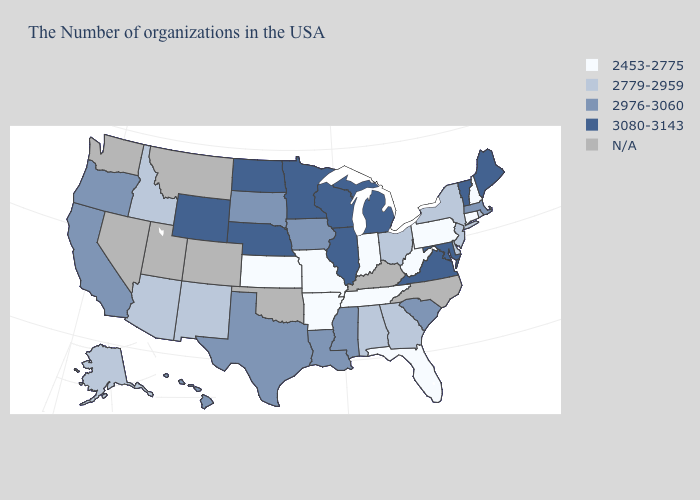Name the states that have a value in the range 2779-2959?
Short answer required. Rhode Island, New York, New Jersey, Delaware, Ohio, Georgia, Alabama, New Mexico, Arizona, Idaho, Alaska. Name the states that have a value in the range 2779-2959?
Write a very short answer. Rhode Island, New York, New Jersey, Delaware, Ohio, Georgia, Alabama, New Mexico, Arizona, Idaho, Alaska. Name the states that have a value in the range 3080-3143?
Write a very short answer. Maine, Vermont, Maryland, Virginia, Michigan, Wisconsin, Illinois, Minnesota, Nebraska, North Dakota, Wyoming. Name the states that have a value in the range 2453-2775?
Give a very brief answer. New Hampshire, Connecticut, Pennsylvania, West Virginia, Florida, Indiana, Tennessee, Missouri, Arkansas, Kansas. Does the first symbol in the legend represent the smallest category?
Short answer required. Yes. Name the states that have a value in the range 2779-2959?
Answer briefly. Rhode Island, New York, New Jersey, Delaware, Ohio, Georgia, Alabama, New Mexico, Arizona, Idaho, Alaska. Does Maine have the highest value in the USA?
Quick response, please. Yes. Which states have the lowest value in the USA?
Quick response, please. New Hampshire, Connecticut, Pennsylvania, West Virginia, Florida, Indiana, Tennessee, Missouri, Arkansas, Kansas. Name the states that have a value in the range 3080-3143?
Be succinct. Maine, Vermont, Maryland, Virginia, Michigan, Wisconsin, Illinois, Minnesota, Nebraska, North Dakota, Wyoming. Name the states that have a value in the range 2779-2959?
Give a very brief answer. Rhode Island, New York, New Jersey, Delaware, Ohio, Georgia, Alabama, New Mexico, Arizona, Idaho, Alaska. What is the value of Massachusetts?
Give a very brief answer. 2976-3060. 